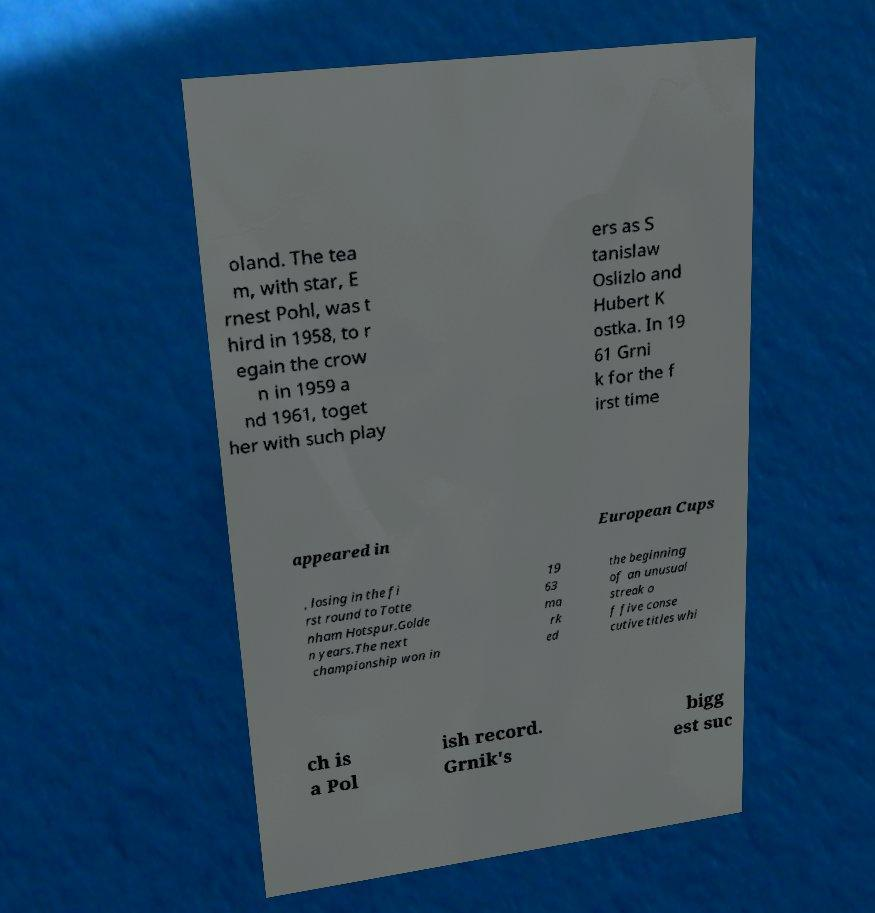What messages or text are displayed in this image? I need them in a readable, typed format. oland. The tea m, with star, E rnest Pohl, was t hird in 1958, to r egain the crow n in 1959 a nd 1961, toget her with such play ers as S tanislaw Oslizlo and Hubert K ostka. In 19 61 Grni k for the f irst time appeared in European Cups , losing in the fi rst round to Totte nham Hotspur.Golde n years.The next championship won in 19 63 ma rk ed the beginning of an unusual streak o f five conse cutive titles whi ch is a Pol ish record. Grnik's bigg est suc 